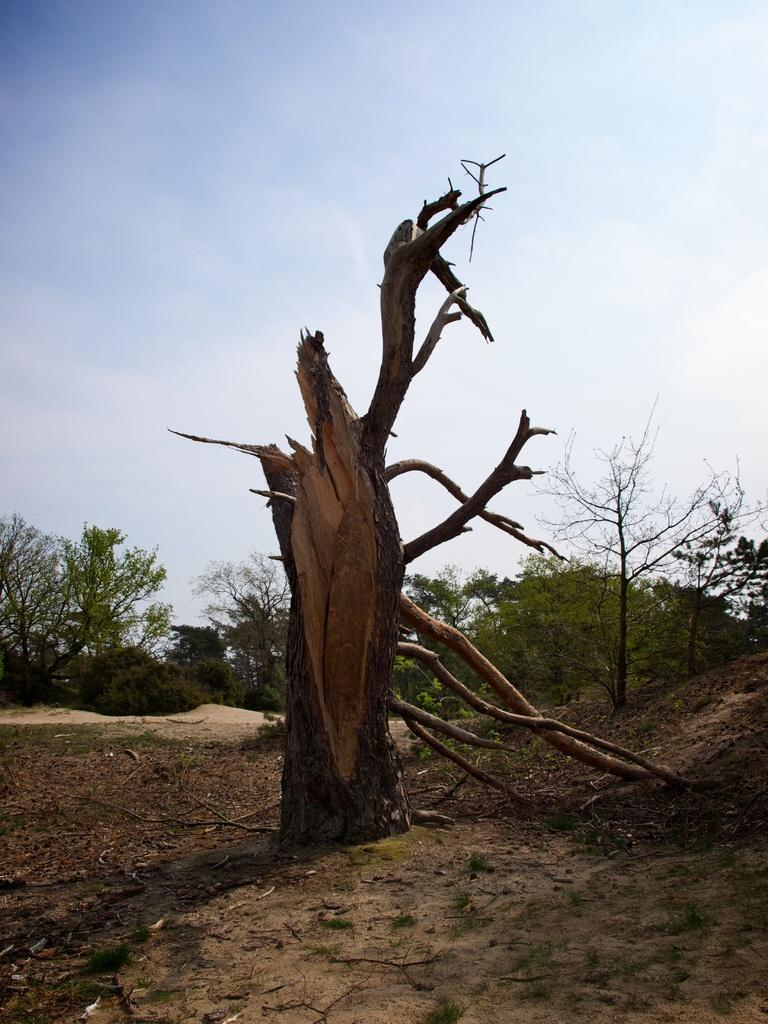What is the main subject of the image? The main subject of the image is a tree trunk and branches. Where are the tree trunk and branches located? The tree trunk and branches are on the ground. What else can be seen in the image besides the tree trunk and branches? There are other plants and trees visible in the image. What type of coat is the tree wearing in the image? There is no coat present in the image, as trees do not wear clothing. 